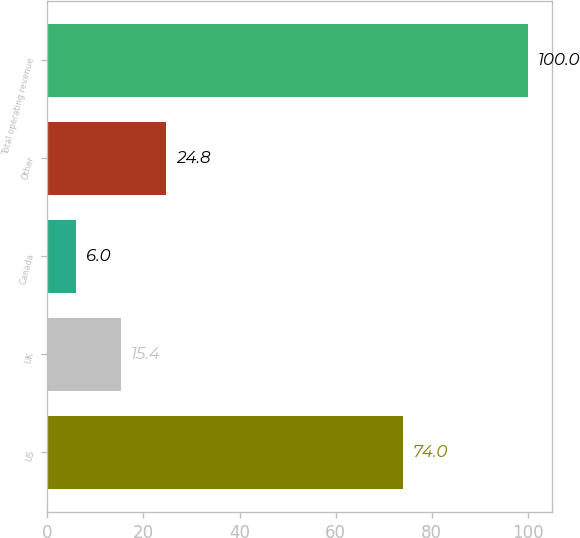Convert chart to OTSL. <chart><loc_0><loc_0><loc_500><loc_500><bar_chart><fcel>US<fcel>UK<fcel>Canada<fcel>Other<fcel>Total operating revenue<nl><fcel>74<fcel>15.4<fcel>6<fcel>24.8<fcel>100<nl></chart> 